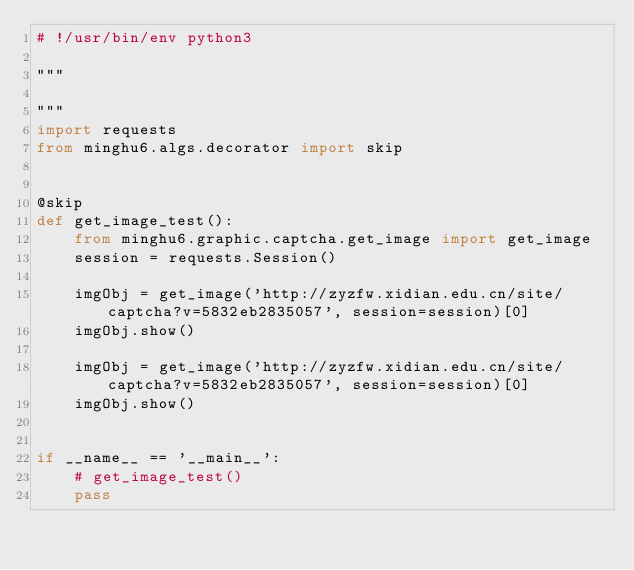Convert code to text. <code><loc_0><loc_0><loc_500><loc_500><_Python_># !/usr/bin/env python3

"""

"""
import requests
from minghu6.algs.decorator import skip


@skip
def get_image_test():
    from minghu6.graphic.captcha.get_image import get_image
    session = requests.Session()

    imgObj = get_image('http://zyzfw.xidian.edu.cn/site/captcha?v=5832eb2835057', session=session)[0]
    imgObj.show()

    imgObj = get_image('http://zyzfw.xidian.edu.cn/site/captcha?v=5832eb2835057', session=session)[0]
    imgObj.show()


if __name__ == '__main__':
    # get_image_test()
    pass
</code> 